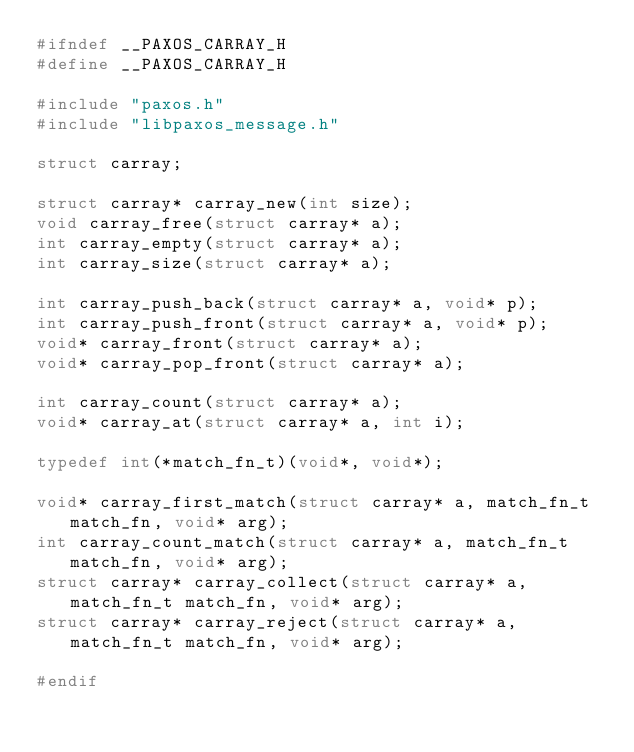<code> <loc_0><loc_0><loc_500><loc_500><_C_>#ifndef __PAXOS_CARRAY_H
#define __PAXOS_CARRAY_H

#include "paxos.h"
#include "libpaxos_message.h"

struct carray;

struct carray* carray_new(int size);
void carray_free(struct carray* a);
int carray_empty(struct carray* a);
int carray_size(struct carray* a);

int carray_push_back(struct carray* a, void* p);
int carray_push_front(struct carray* a, void* p);
void* carray_front(struct carray* a);
void* carray_pop_front(struct carray* a);

int	carray_count(struct carray* a);
void* carray_at(struct carray* a, int i);

typedef int(*match_fn_t)(void*, void*);

void* carray_first_match(struct carray* a, match_fn_t match_fn, void* arg);
int carray_count_match(struct carray* a, match_fn_t match_fn, void* arg);
struct carray* carray_collect(struct carray* a, match_fn_t match_fn, void* arg);
struct carray* carray_reject(struct carray* a, match_fn_t match_fn, void* arg);

#endif
</code> 